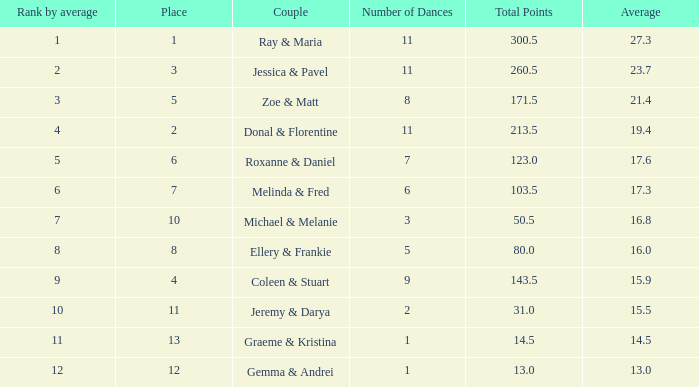If your rank by average is 9, what is the name of the couple? Coleen & Stuart. 